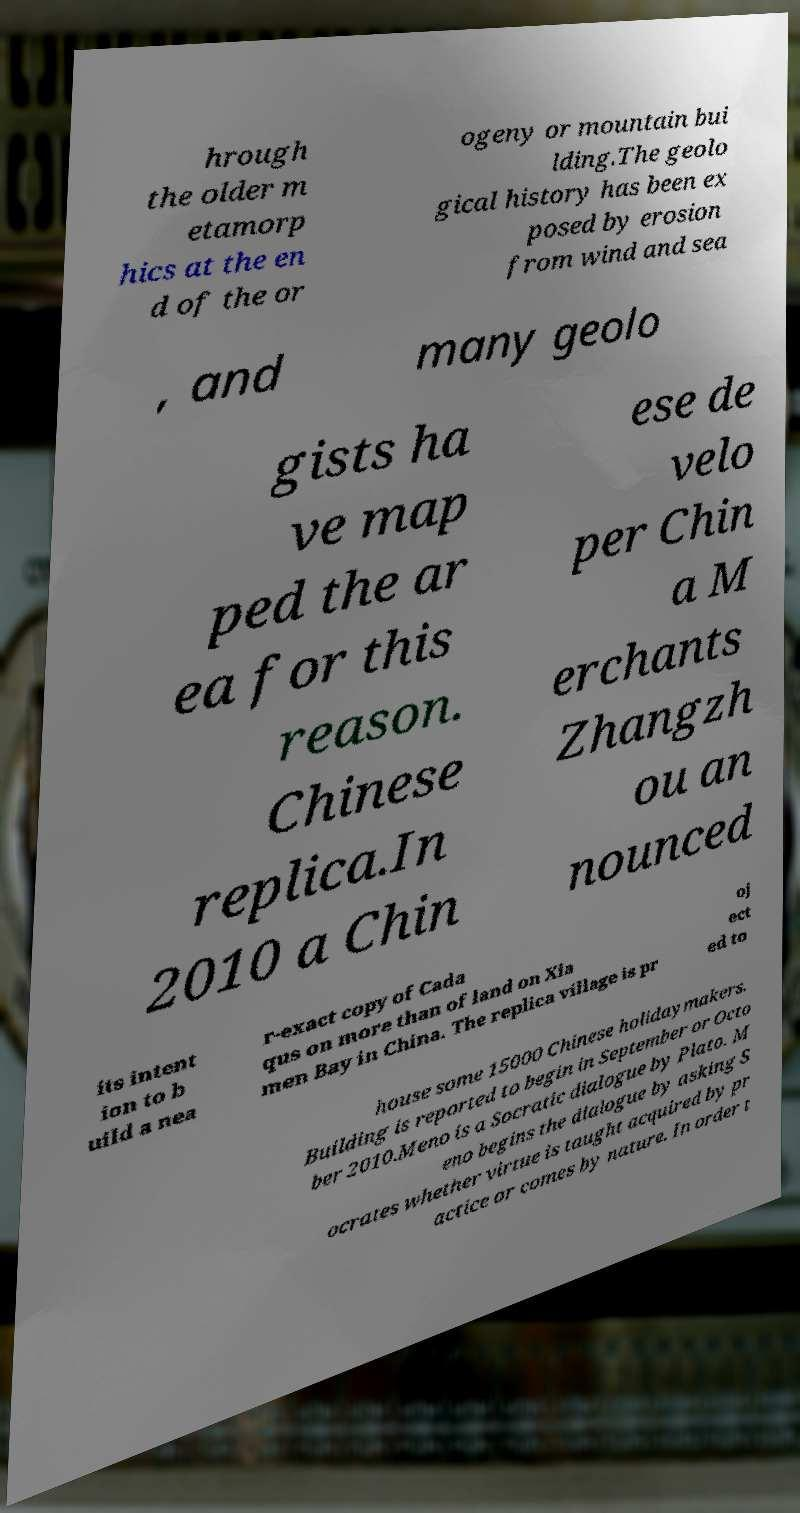There's text embedded in this image that I need extracted. Can you transcribe it verbatim? hrough the older m etamorp hics at the en d of the or ogeny or mountain bui lding.The geolo gical history has been ex posed by erosion from wind and sea , and many geolo gists ha ve map ped the ar ea for this reason. Chinese replica.In 2010 a Chin ese de velo per Chin a M erchants Zhangzh ou an nounced its intent ion to b uild a nea r-exact copy of Cada qus on more than of land on Xia men Bay in China. The replica village is pr oj ect ed to house some 15000 Chinese holidaymakers. Building is reported to begin in September or Octo ber 2010.Meno is a Socratic dialogue by Plato. M eno begins the dialogue by asking S ocrates whether virtue is taught acquired by pr actice or comes by nature. In order t 